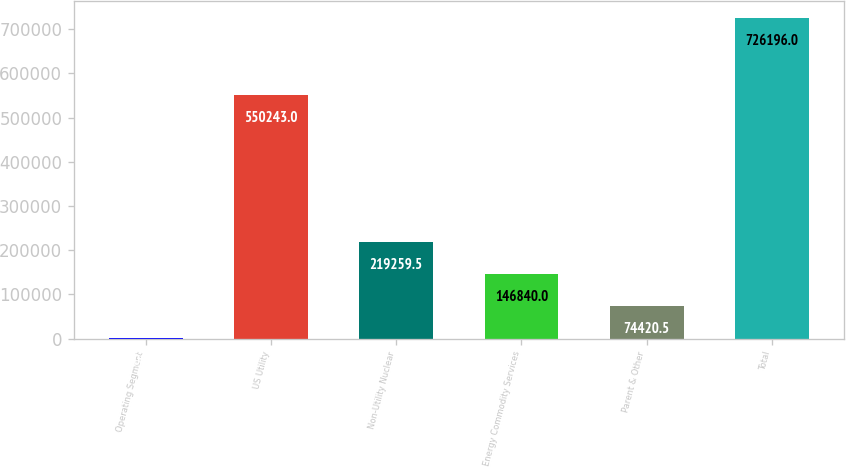Convert chart to OTSL. <chart><loc_0><loc_0><loc_500><loc_500><bar_chart><fcel>Operating Segment<fcel>US Utility<fcel>Non-Utility Nuclear<fcel>Energy Commodity Services<fcel>Parent & Other<fcel>Total<nl><fcel>2001<fcel>550243<fcel>219260<fcel>146840<fcel>74420.5<fcel>726196<nl></chart> 